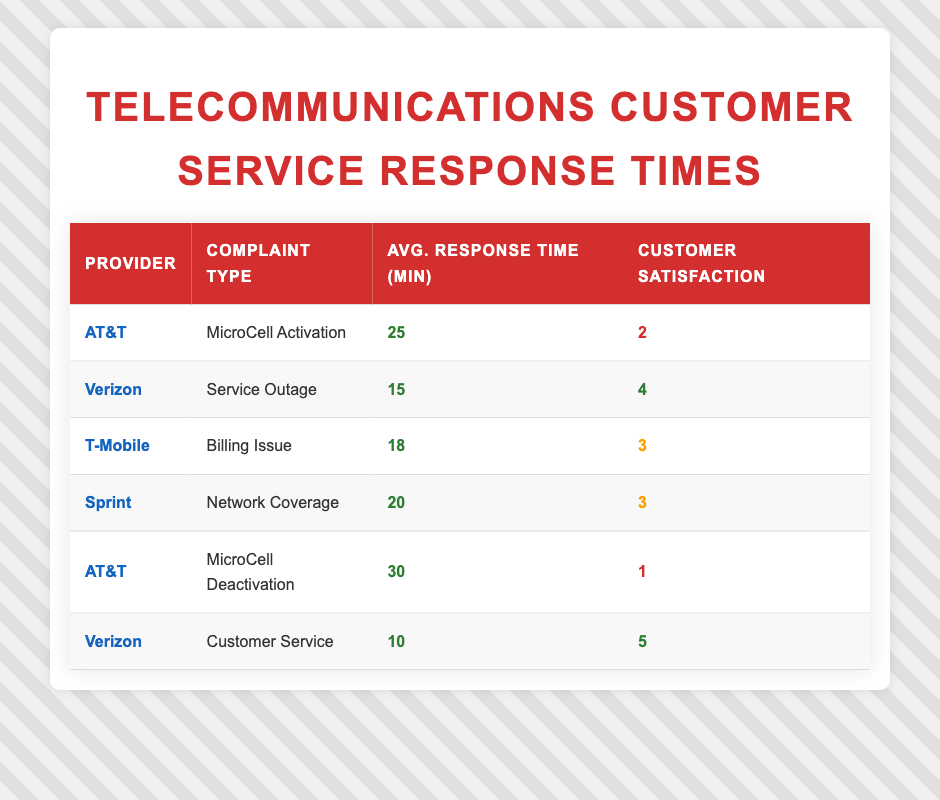What is the average response time for AT&T's MicroCell Deactivation complaints? The average response time for AT&T's MicroCell Deactivation is stated in the table as 30 minutes.
Answer: 30 Which provider has the highest customer satisfaction rating? The highest customer satisfaction rating in the table is 5, which belongs to Verizon for the Customer Service complaint.
Answer: Verizon What is the average customer satisfaction rating for complaints related to AT&T? The two complaints related to AT&T are MicroCell Activation (rating 2) and MicroCell Deactivation (rating 1). Their average is (2 + 1) / 2 = 1.5.
Answer: 1.5 Is the average response time for Verizon's Service Outage complaints less than 15 minutes? The average response time for Verizon's Service Outage complaints is 15 minutes, so it is not less than 15 minutes.
Answer: No Which provider has the quickest response time overall? By comparing all response times listed, Verizon has the quickest response time of 10 minutes for Customer Service.
Answer: Verizon 